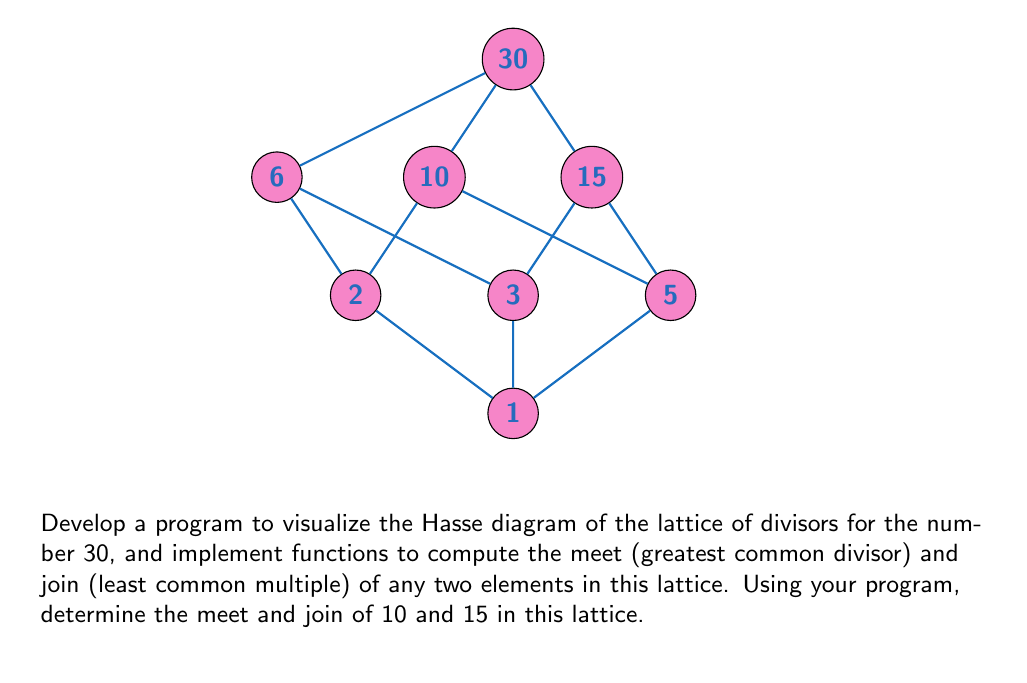Could you help me with this problem? To solve this problem, we need to understand the concepts of lattices, Hasse diagrams, and the operations of meet and join in the context of divisor lattices. Let's break it down step-by-step:

1. Lattice of divisors:
   The lattice of divisors for 30 consists of all positive integers that divide 30 evenly. These are: 1, 2, 3, 5, 6, 10, 15, and 30.

2. Hasse diagram:
   The Hasse diagram represents the partial order of these divisors, with edges connecting each element to its immediate successors. The diagram is provided in the question.

3. Meet operation (greatest common divisor):
   The meet of two elements in a divisor lattice is their greatest common divisor (GCD).
   To compute GCD(10, 15):
   $GCD(10, 15) = GCD(10, 5) = 5$

4. Join operation (least common multiple):
   The join of two elements in a divisor lattice is their least common multiple (LCM).
   To compute LCM(10, 15):
   $LCM(10, 15) = \frac{10 \times 15}{GCD(10, 15)} = \frac{150}{5} = 30$

5. Visualization in the Hasse diagram:
   - The meet (5) is the highest element in the diagram that is below both 10 and 15.
   - The join (30) is the lowest element in the diagram that is above both 10 and 15.

To implement this in a programming language for abstract algebra concepts:

1. Create a data structure to represent the lattice (e.g., a graph or a dictionary of sets).
2. Implement functions for meet and join operations using GCD and LCM algorithms.
3. Create a function to generate and display the Hasse diagram.
4. Provide an interface to input elements and compute their meet and join.

The program would then use these implementations to visualize the lattice and compute the required operations.
Answer: Meet(10, 15) = 5, Join(10, 15) = 30 